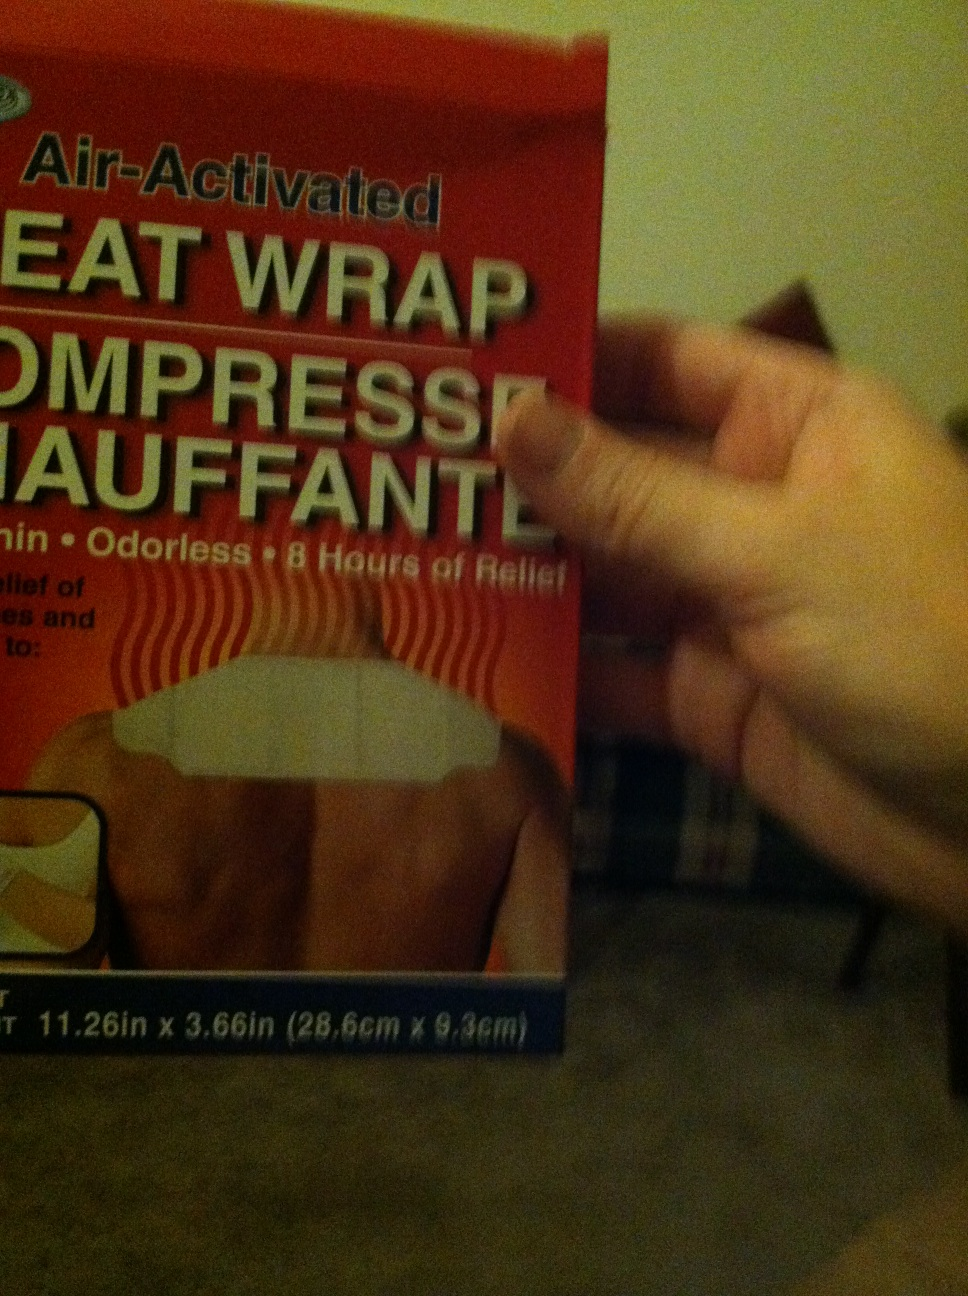Can you tell me what this is please? This is a heat wrap, specifically an air-activated compress that offers odorless heat therapy for up to 8 hours. It's designed to provide relief from aches and pains. 